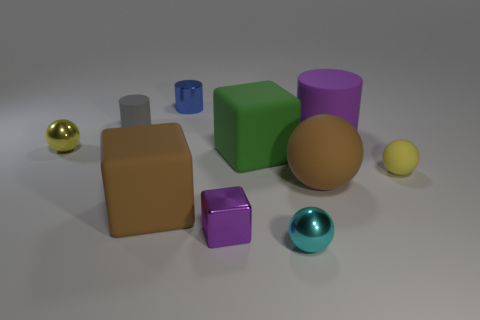Subtract all small cylinders. How many cylinders are left? 1 Subtract all brown cylinders. How many yellow spheres are left? 2 Subtract all yellow balls. How many balls are left? 2 Subtract 1 spheres. How many spheres are left? 3 Subtract all spheres. How many objects are left? 6 Subtract all cyan cylinders. Subtract all brown balls. How many cylinders are left? 3 Subtract all yellow shiny cylinders. Subtract all small shiny balls. How many objects are left? 8 Add 6 tiny blue shiny things. How many tiny blue shiny things are left? 7 Add 1 gray things. How many gray things exist? 2 Subtract 1 gray cylinders. How many objects are left? 9 